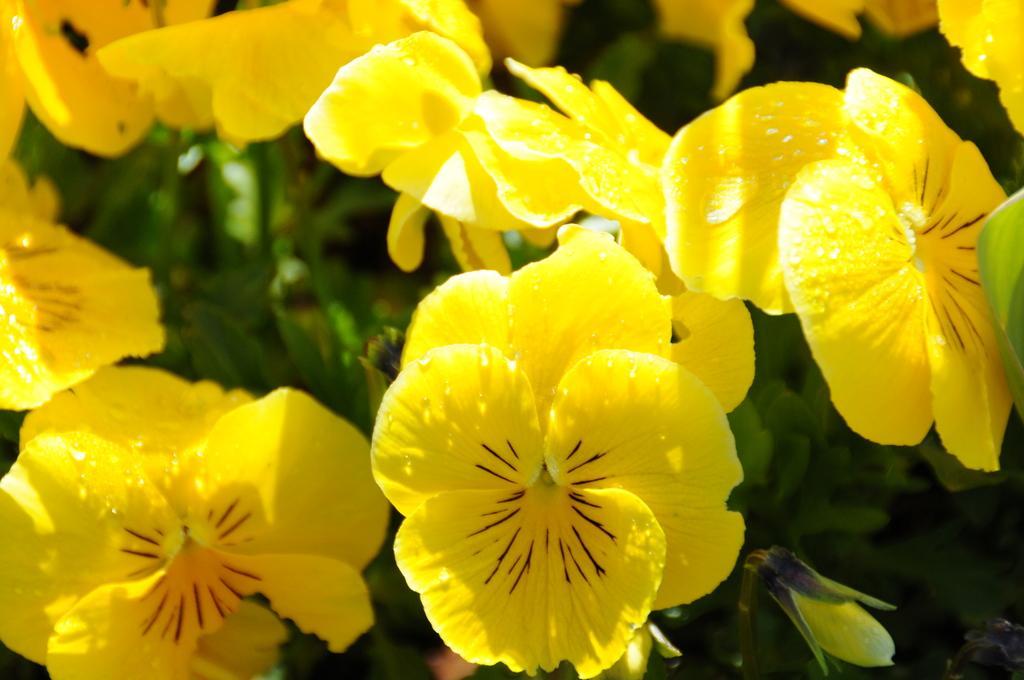Please provide a concise description of this image. In this picture we can see yellow flowers and in the background we can see leaves. 